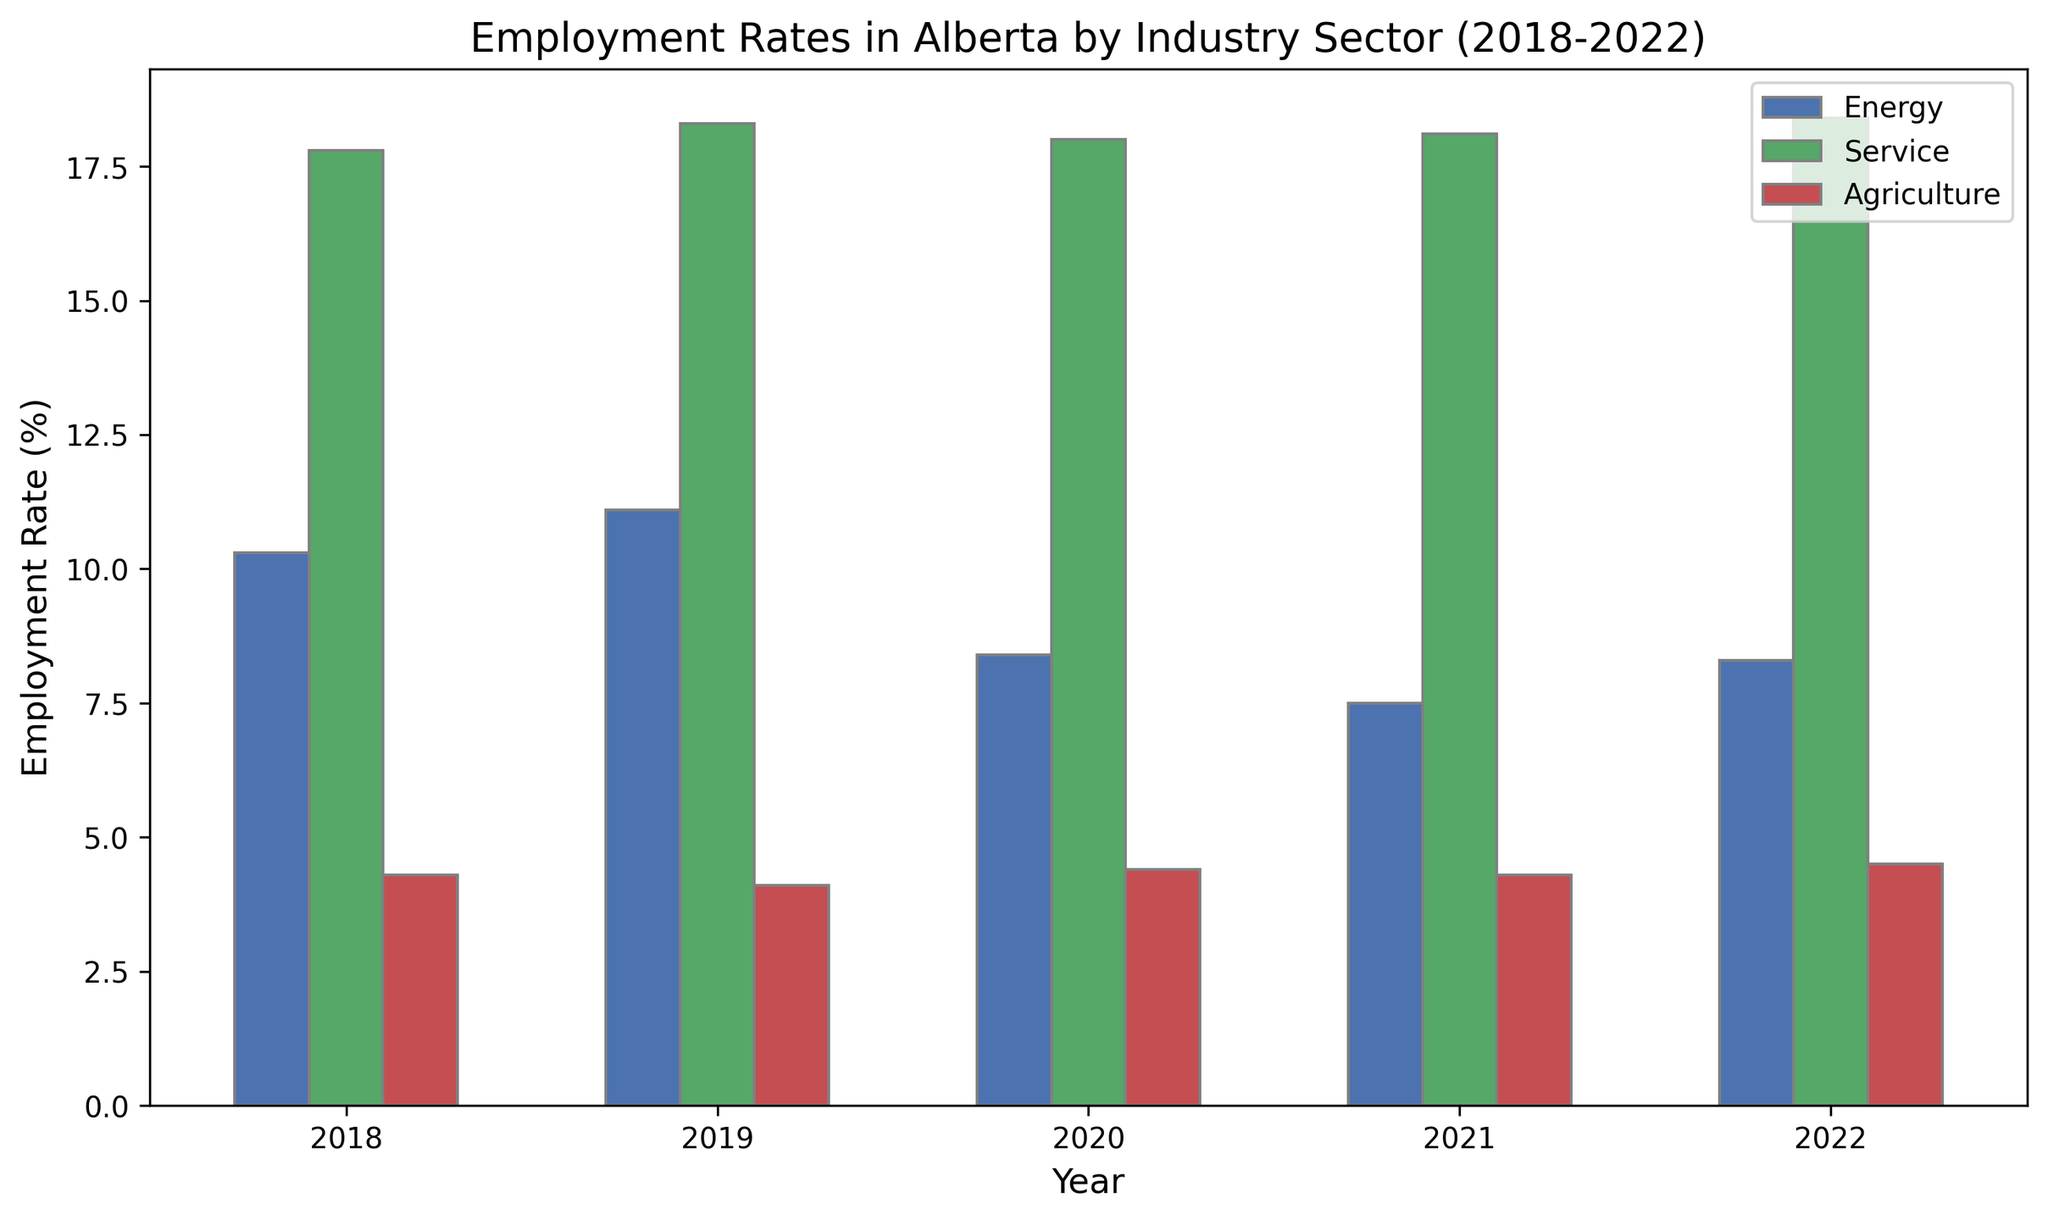Which industry sector had the highest employment rate in 2022? The bars in the plot indicate employment rates for different sectors in different years. The highest bar for 2022 belongs to the Service sector.
Answer: Service How did the agriculture employment rate in 2020 compare to that in 2021? By visually comparing the heights of bars for agriculture in 2020 and 2021, we observe that they are the same height. The employment rates for both years are equal.
Answer: Equal Which year saw a decrease in the energy sector's employment rate compared to the previous year? By comparing the heights of consecutive bars for the energy sector, we can see that the bar for 2020 is shorter than the bar for 2019, indicating a decrease.
Answer: 2020 What is the average employment rate for the energy sector from 2018 to 2022? Sum the employment rates for the energy sector over the years (10.3 + 11.1 + 8.4 + 7.5 + 8.3 = 45.6), then divide by the number of years (45.6 / 5).
Answer: 9.12 Which sector had the smallest change in employment rate from 2018 to 2022? By visually inspecting the bars from 2018 to 2022 for each sector, the agriculture sector seems to have the smallest difference between the bars. Comparing the initial and final values confirms this: 4.3 in 2018 and 4.5 in 2022, showing only a slight increase.
Answer: Agriculture In which year was there the biggest difference in employment rates between the service and energy sectors? Looking at the height differences for the service and energy sector bars year by year, the biggest difference appears in 2021. Calculating numerically: service 18.1 - energy 7.5 = 10.6.
Answer: 2021 How does the visual height of the 2021 employment rate bar for the service sector compare to the 2022 bar? The bars for the service sector in 2021 and 2022 show a slight increase for 2022 when visually compared. The 2022 bar is slightly taller than the 2021 bar.
Answer: Slightly taller What was the general trend in the employment rate for the energy sector over the period 2018-2022? The bars for the energy sector show a decrease from 2018 to 2021, followed by a slight increase in 2022. The trend is a decrease overall, with a small rebound at the end.
Answer: Decrease and then a slight increase 